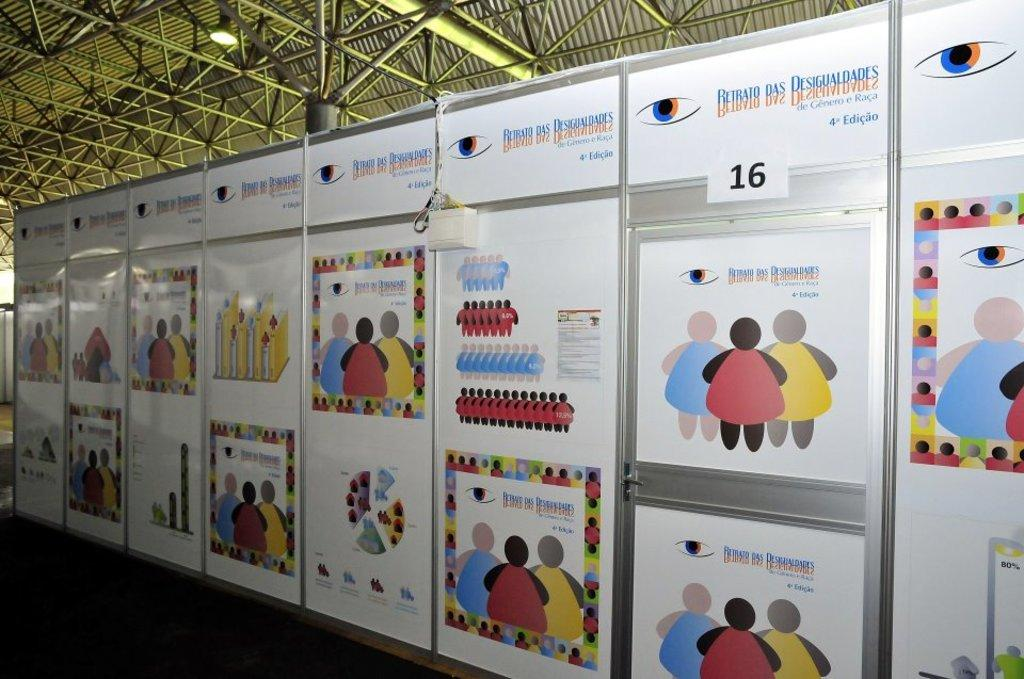Provide a one-sentence caption for the provided image. A wall of posters featuring cartoon people for Retrato das Desigualdades. 